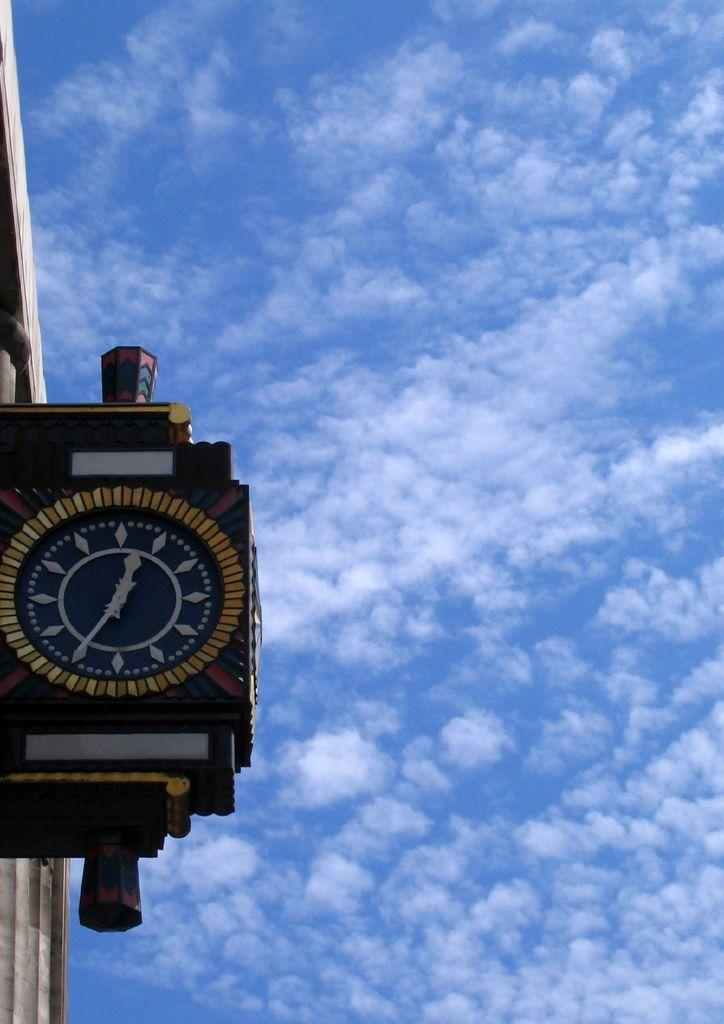What is the main object in the image? There is a clock in the image. Is the clock connected to anything else? The clock is attached to an object. What can be seen in the background of the image? The sky is visible in the background of the image. How does the clock contribute to the development of society in the image? The image does not show any indication of the clock's impact on society, as it only depicts the clock and its attachment to another object. 